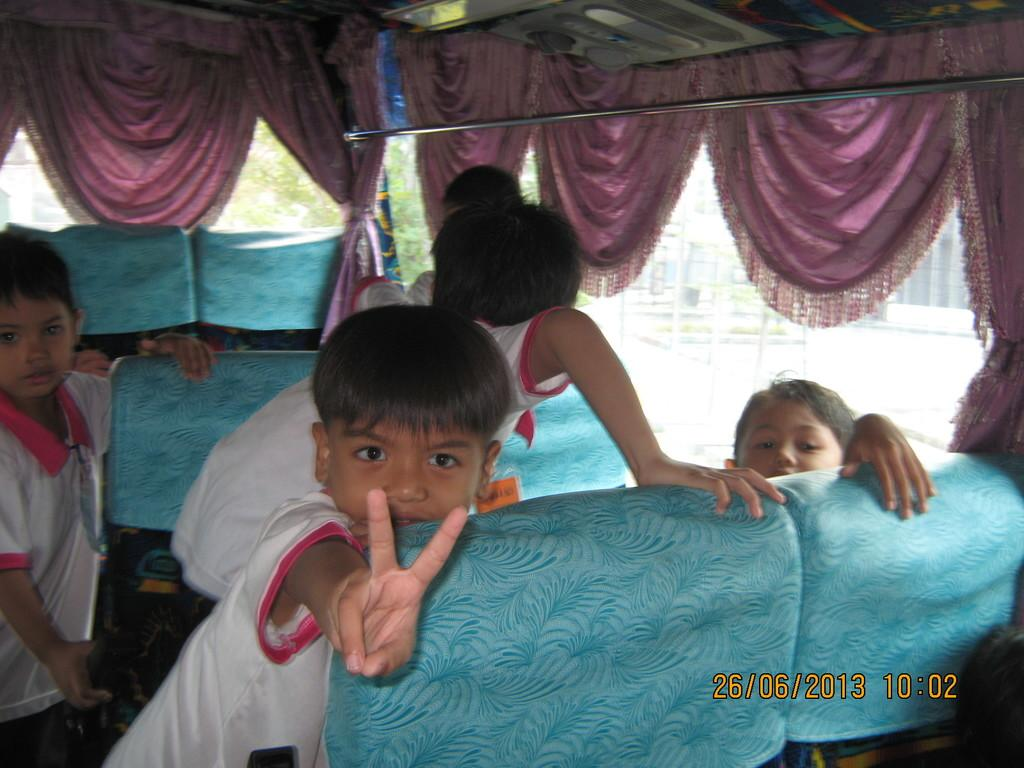What type of vehicle is shown in the image? The image is an inside view of a bus. What can be found inside the bus? There are seats in the bus. Who is present in the bus? There are many children in the bus. Are there any window treatments in the bus? Yes, there are curtains in the bus. What material is the steel rod made of? The steel rod in the bus is made of steel. Can you see any flowers hanging from the ceiling in the image? No, there are no flowers visible in the image. 